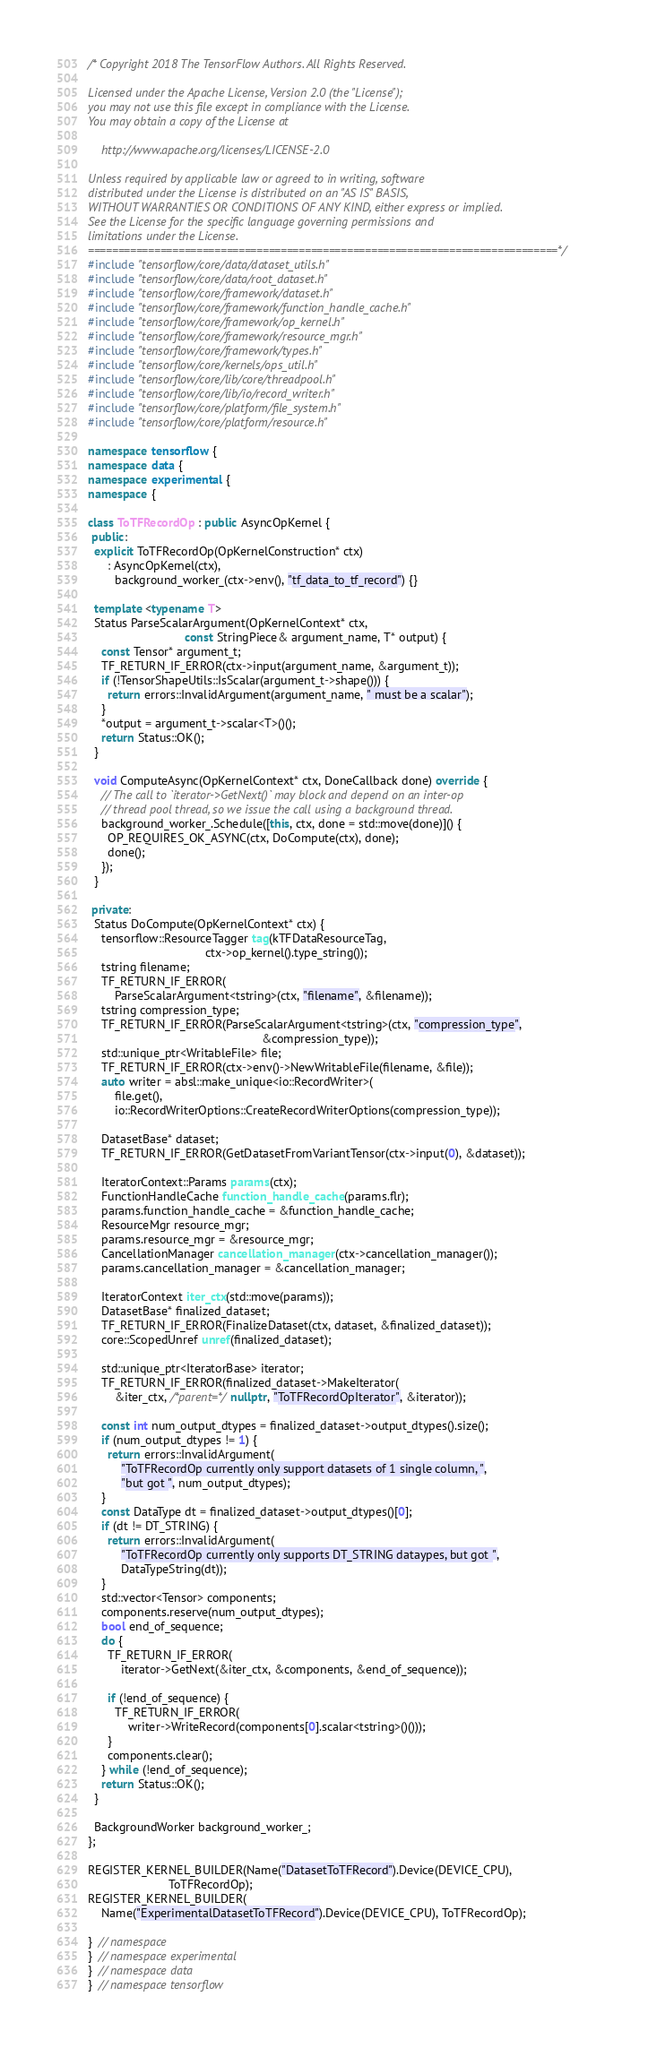Convert code to text. <code><loc_0><loc_0><loc_500><loc_500><_C++_>/* Copyright 2018 The TensorFlow Authors. All Rights Reserved.

Licensed under the Apache License, Version 2.0 (the "License");
you may not use this file except in compliance with the License.
You may obtain a copy of the License at

    http://www.apache.org/licenses/LICENSE-2.0

Unless required by applicable law or agreed to in writing, software
distributed under the License is distributed on an "AS IS" BASIS,
WITHOUT WARRANTIES OR CONDITIONS OF ANY KIND, either express or implied.
See the License for the specific language governing permissions and
limitations under the License.
==============================================================================*/
#include "tensorflow/core/data/dataset_utils.h"
#include "tensorflow/core/data/root_dataset.h"
#include "tensorflow/core/framework/dataset.h"
#include "tensorflow/core/framework/function_handle_cache.h"
#include "tensorflow/core/framework/op_kernel.h"
#include "tensorflow/core/framework/resource_mgr.h"
#include "tensorflow/core/framework/types.h"
#include "tensorflow/core/kernels/ops_util.h"
#include "tensorflow/core/lib/core/threadpool.h"
#include "tensorflow/core/lib/io/record_writer.h"
#include "tensorflow/core/platform/file_system.h"
#include "tensorflow/core/platform/resource.h"

namespace tensorflow {
namespace data {
namespace experimental {
namespace {

class ToTFRecordOp : public AsyncOpKernel {
 public:
  explicit ToTFRecordOp(OpKernelConstruction* ctx)
      : AsyncOpKernel(ctx),
        background_worker_(ctx->env(), "tf_data_to_tf_record") {}

  template <typename T>
  Status ParseScalarArgument(OpKernelContext* ctx,
                             const StringPiece& argument_name, T* output) {
    const Tensor* argument_t;
    TF_RETURN_IF_ERROR(ctx->input(argument_name, &argument_t));
    if (!TensorShapeUtils::IsScalar(argument_t->shape())) {
      return errors::InvalidArgument(argument_name, " must be a scalar");
    }
    *output = argument_t->scalar<T>()();
    return Status::OK();
  }

  void ComputeAsync(OpKernelContext* ctx, DoneCallback done) override {
    // The call to `iterator->GetNext()` may block and depend on an inter-op
    // thread pool thread, so we issue the call using a background thread.
    background_worker_.Schedule([this, ctx, done = std::move(done)]() {
      OP_REQUIRES_OK_ASYNC(ctx, DoCompute(ctx), done);
      done();
    });
  }

 private:
  Status DoCompute(OpKernelContext* ctx) {
    tensorflow::ResourceTagger tag(kTFDataResourceTag,
                                   ctx->op_kernel().type_string());
    tstring filename;
    TF_RETURN_IF_ERROR(
        ParseScalarArgument<tstring>(ctx, "filename", &filename));
    tstring compression_type;
    TF_RETURN_IF_ERROR(ParseScalarArgument<tstring>(ctx, "compression_type",
                                                    &compression_type));
    std::unique_ptr<WritableFile> file;
    TF_RETURN_IF_ERROR(ctx->env()->NewWritableFile(filename, &file));
    auto writer = absl::make_unique<io::RecordWriter>(
        file.get(),
        io::RecordWriterOptions::CreateRecordWriterOptions(compression_type));

    DatasetBase* dataset;
    TF_RETURN_IF_ERROR(GetDatasetFromVariantTensor(ctx->input(0), &dataset));

    IteratorContext::Params params(ctx);
    FunctionHandleCache function_handle_cache(params.flr);
    params.function_handle_cache = &function_handle_cache;
    ResourceMgr resource_mgr;
    params.resource_mgr = &resource_mgr;
    CancellationManager cancellation_manager(ctx->cancellation_manager());
    params.cancellation_manager = &cancellation_manager;

    IteratorContext iter_ctx(std::move(params));
    DatasetBase* finalized_dataset;
    TF_RETURN_IF_ERROR(FinalizeDataset(ctx, dataset, &finalized_dataset));
    core::ScopedUnref unref(finalized_dataset);

    std::unique_ptr<IteratorBase> iterator;
    TF_RETURN_IF_ERROR(finalized_dataset->MakeIterator(
        &iter_ctx, /*parent=*/nullptr, "ToTFRecordOpIterator", &iterator));

    const int num_output_dtypes = finalized_dataset->output_dtypes().size();
    if (num_output_dtypes != 1) {
      return errors::InvalidArgument(
          "ToTFRecordOp currently only support datasets of 1 single column, ",
          "but got ", num_output_dtypes);
    }
    const DataType dt = finalized_dataset->output_dtypes()[0];
    if (dt != DT_STRING) {
      return errors::InvalidArgument(
          "ToTFRecordOp currently only supports DT_STRING dataypes, but got ",
          DataTypeString(dt));
    }
    std::vector<Tensor> components;
    components.reserve(num_output_dtypes);
    bool end_of_sequence;
    do {
      TF_RETURN_IF_ERROR(
          iterator->GetNext(&iter_ctx, &components, &end_of_sequence));

      if (!end_of_sequence) {
        TF_RETURN_IF_ERROR(
            writer->WriteRecord(components[0].scalar<tstring>()()));
      }
      components.clear();
    } while (!end_of_sequence);
    return Status::OK();
  }

  BackgroundWorker background_worker_;
};

REGISTER_KERNEL_BUILDER(Name("DatasetToTFRecord").Device(DEVICE_CPU),
                        ToTFRecordOp);
REGISTER_KERNEL_BUILDER(
    Name("ExperimentalDatasetToTFRecord").Device(DEVICE_CPU), ToTFRecordOp);

}  // namespace
}  // namespace experimental
}  // namespace data
}  // namespace tensorflow
</code> 